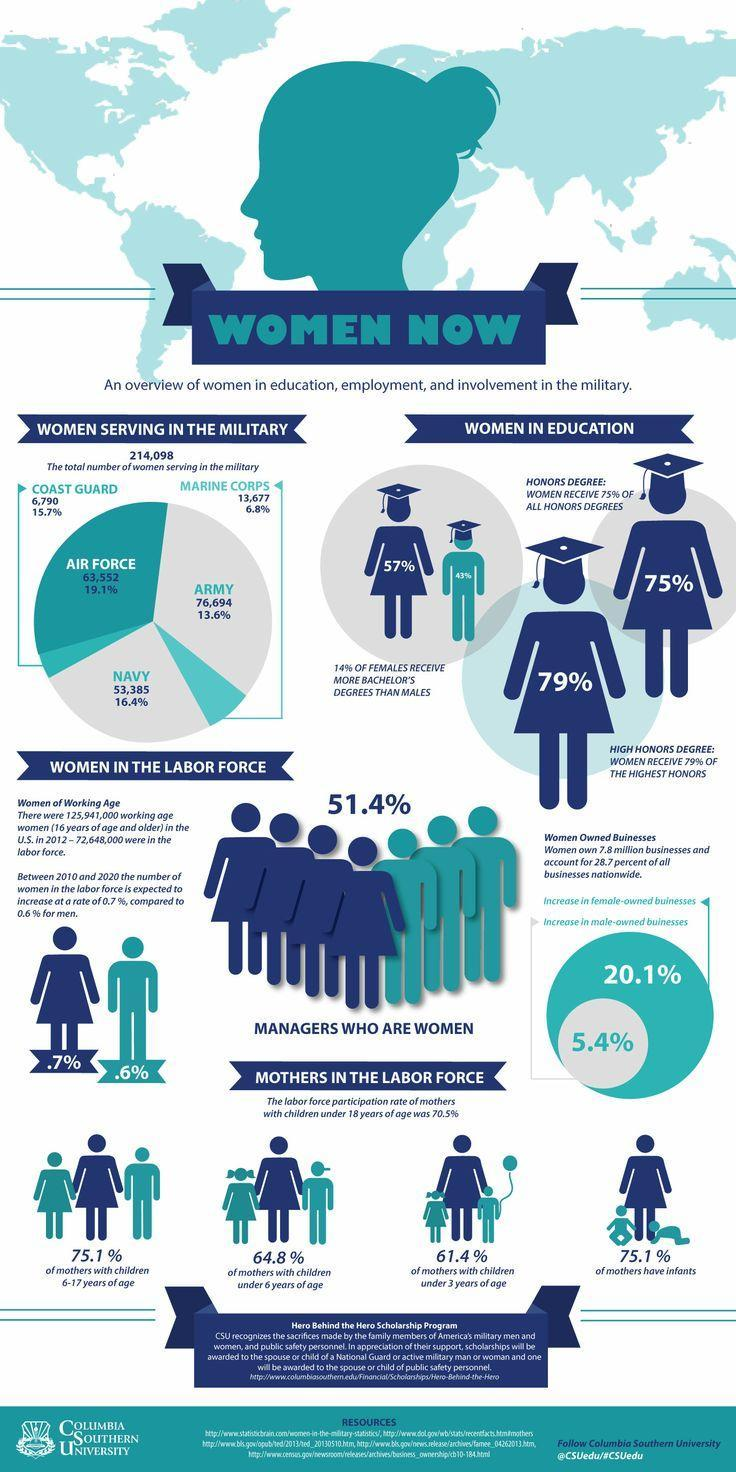What percent of women are working in the managerial position in the U.S.?
Answer the question with a short phrase. 51.4% What is the percentage increase seen in the male-owned businesses in the U.S.? 5.4% What is the total number of women serving in the U.S. Air Force? 63,552 What is the total number of women serving in the army services of the U.S.? 76,694 What percentage of mothers of infants are in the labor force in the U.S.? 75.1% What percentage of females have owned a bachelor's degree in the U.S.? 57% What percentage of women are in the Navy services of the U.S.? 16.4% What is the percentage increase seen in the female-owned businesses in the U.S.? 20.1% What percentage of mothers of children under 6 years of age are in the labor force of the U.S.? 64.8% 